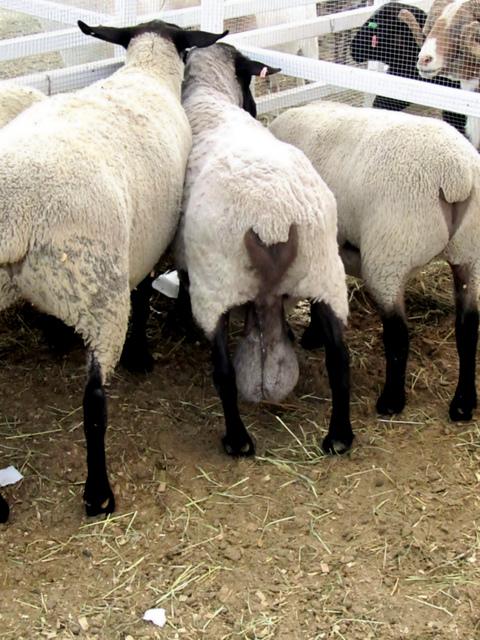Are the three animals facing a corner?
Answer briefly. Yes. How many animals are there?
Give a very brief answer. 6. Are the animals with small tails?
Answer briefly. Yes. What is holding the animals in?
Give a very brief answer. Fence. What are the sheep eating?
Answer briefly. Hay. 